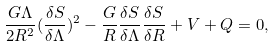Convert formula to latex. <formula><loc_0><loc_0><loc_500><loc_500>\frac { G \Lambda } { 2 R ^ { 2 } } ( \frac { \delta S } { \delta \Lambda } ) ^ { 2 } - \frac { G } { R } \frac { \delta S } { \delta \Lambda } \frac { \delta S } { \delta R } + V + Q = 0 ,</formula> 